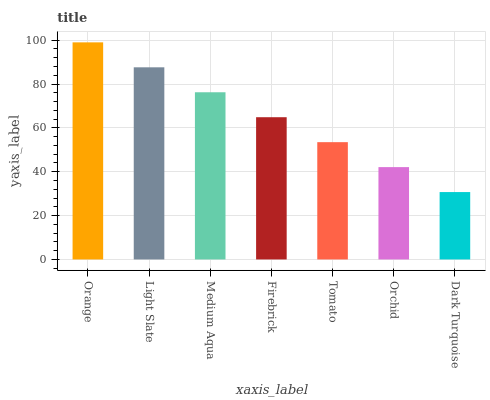Is Light Slate the minimum?
Answer yes or no. No. Is Light Slate the maximum?
Answer yes or no. No. Is Orange greater than Light Slate?
Answer yes or no. Yes. Is Light Slate less than Orange?
Answer yes or no. Yes. Is Light Slate greater than Orange?
Answer yes or no. No. Is Orange less than Light Slate?
Answer yes or no. No. Is Firebrick the high median?
Answer yes or no. Yes. Is Firebrick the low median?
Answer yes or no. Yes. Is Tomato the high median?
Answer yes or no. No. Is Orange the low median?
Answer yes or no. No. 